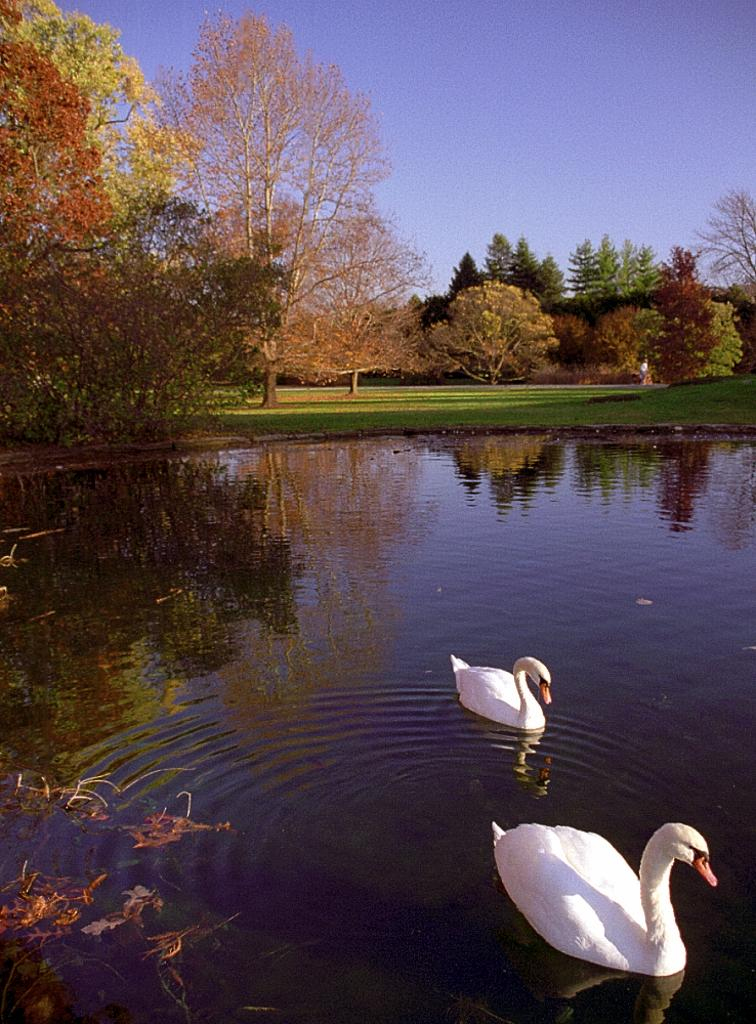What animals are in the water in the image? There are two swans in the water in the image. What type of vegetation can be seen in the background of the image? There is grass and trees in the background of the image. What part of the natural environment is visible in the image? The sky is visible in the background of the image. What can be inferred about the weather during the time the image was taken? The image may have been taken during a sunny day, as the sky appears clear. Where might this image have been taken? The image may have been taken near a lake, given the presence of water and swans. Can you tell me how many people are wearing hats in the image? There are no people or hats present in the image; it features two swans in the water. What type of trees are visible in the image? The image does not specify the type of trees; it only mentions that there are trees in the background. 